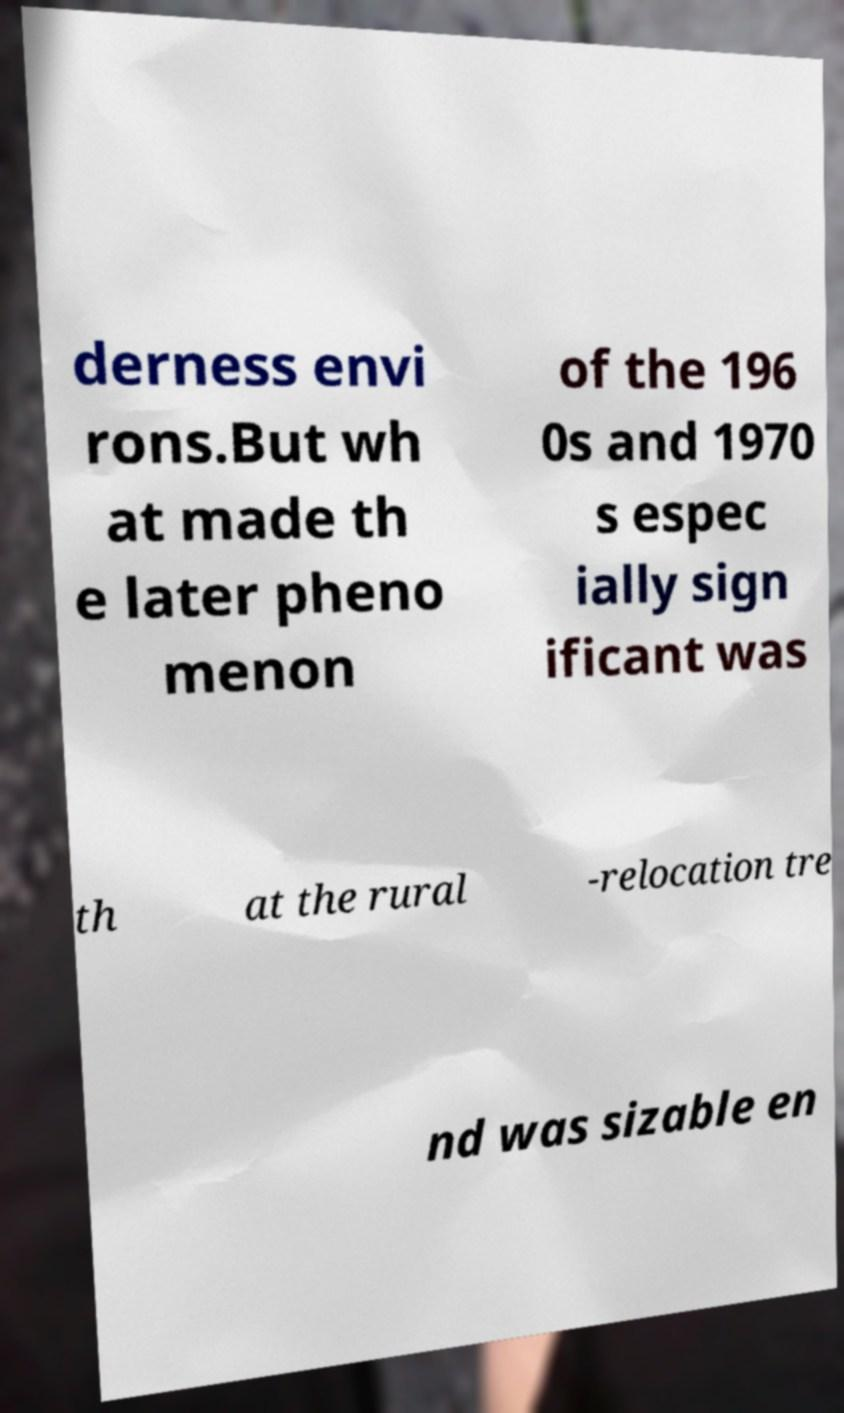I need the written content from this picture converted into text. Can you do that? derness envi rons.But wh at made th e later pheno menon of the 196 0s and 1970 s espec ially sign ificant was th at the rural -relocation tre nd was sizable en 